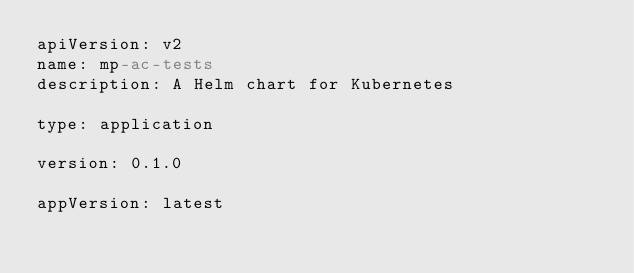Convert code to text. <code><loc_0><loc_0><loc_500><loc_500><_YAML_>apiVersion: v2
name: mp-ac-tests
description: A Helm chart for Kubernetes

type: application

version: 0.1.0

appVersion: latest
</code> 